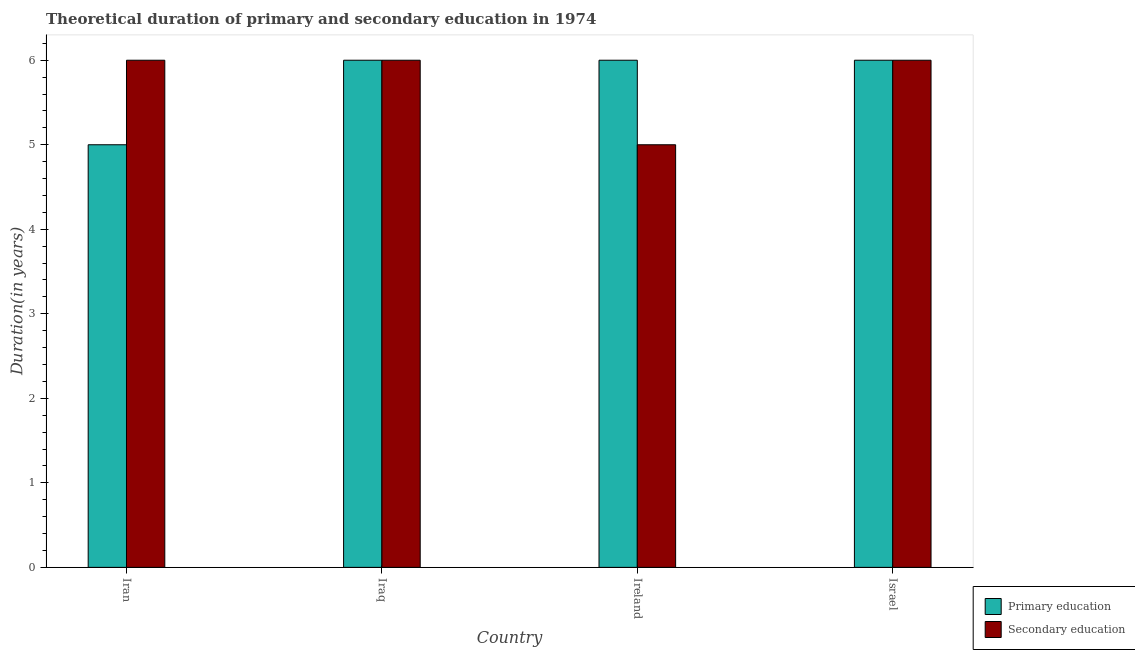How many bars are there on the 4th tick from the left?
Your answer should be compact. 2. What is the label of the 2nd group of bars from the left?
Keep it short and to the point. Iraq. In how many cases, is the number of bars for a given country not equal to the number of legend labels?
Your response must be concise. 0. Across all countries, what is the maximum duration of primary education?
Your answer should be very brief. 6. Across all countries, what is the minimum duration of secondary education?
Provide a succinct answer. 5. In which country was the duration of secondary education maximum?
Your answer should be compact. Iran. In which country was the duration of primary education minimum?
Offer a terse response. Iran. What is the total duration of secondary education in the graph?
Offer a terse response. 23. What is the difference between the duration of primary education in Israel and the duration of secondary education in Ireland?
Give a very brief answer. 1. What is the average duration of secondary education per country?
Ensure brevity in your answer.  5.75. What is the difference between the duration of secondary education and duration of primary education in Iran?
Your answer should be compact. 1. In how many countries, is the duration of secondary education greater than 1.8 years?
Keep it short and to the point. 4. Is the duration of primary education in Iran less than that in Israel?
Your answer should be compact. Yes. What is the difference between the highest and the lowest duration of secondary education?
Offer a very short reply. 1. In how many countries, is the duration of secondary education greater than the average duration of secondary education taken over all countries?
Give a very brief answer. 3. What does the 2nd bar from the left in Iran represents?
Give a very brief answer. Secondary education. What does the 2nd bar from the right in Ireland represents?
Offer a terse response. Primary education. Are all the bars in the graph horizontal?
Give a very brief answer. No. How many countries are there in the graph?
Your answer should be very brief. 4. What is the difference between two consecutive major ticks on the Y-axis?
Your response must be concise. 1. Does the graph contain any zero values?
Your answer should be very brief. No. Does the graph contain grids?
Provide a succinct answer. No. Where does the legend appear in the graph?
Provide a short and direct response. Bottom right. How are the legend labels stacked?
Provide a succinct answer. Vertical. What is the title of the graph?
Provide a succinct answer. Theoretical duration of primary and secondary education in 1974. What is the label or title of the X-axis?
Offer a terse response. Country. What is the label or title of the Y-axis?
Ensure brevity in your answer.  Duration(in years). What is the Duration(in years) in Primary education in Ireland?
Your response must be concise. 6. What is the Duration(in years) of Primary education in Israel?
Your answer should be very brief. 6. What is the Duration(in years) of Secondary education in Israel?
Keep it short and to the point. 6. Across all countries, what is the maximum Duration(in years) of Primary education?
Your response must be concise. 6. Across all countries, what is the maximum Duration(in years) of Secondary education?
Offer a terse response. 6. What is the total Duration(in years) in Primary education in the graph?
Provide a succinct answer. 23. What is the total Duration(in years) of Secondary education in the graph?
Make the answer very short. 23. What is the difference between the Duration(in years) of Primary education in Iran and that in Iraq?
Provide a succinct answer. -1. What is the difference between the Duration(in years) in Secondary education in Iran and that in Iraq?
Your response must be concise. 0. What is the difference between the Duration(in years) in Primary education in Iran and that in Ireland?
Ensure brevity in your answer.  -1. What is the difference between the Duration(in years) of Secondary education in Iran and that in Ireland?
Keep it short and to the point. 1. What is the difference between the Duration(in years) in Primary education in Iran and that in Israel?
Provide a short and direct response. -1. What is the difference between the Duration(in years) of Secondary education in Iraq and that in Ireland?
Your answer should be very brief. 1. What is the difference between the Duration(in years) in Primary education in Ireland and that in Israel?
Your response must be concise. 0. What is the difference between the Duration(in years) in Secondary education in Ireland and that in Israel?
Your response must be concise. -1. What is the difference between the Duration(in years) in Primary education in Iran and the Duration(in years) in Secondary education in Iraq?
Keep it short and to the point. -1. What is the difference between the Duration(in years) in Primary education in Ireland and the Duration(in years) in Secondary education in Israel?
Offer a terse response. 0. What is the average Duration(in years) in Primary education per country?
Offer a very short reply. 5.75. What is the average Duration(in years) of Secondary education per country?
Your answer should be compact. 5.75. What is the difference between the Duration(in years) in Primary education and Duration(in years) in Secondary education in Iraq?
Offer a terse response. 0. What is the ratio of the Duration(in years) of Primary education in Iran to that in Iraq?
Your answer should be compact. 0.83. What is the ratio of the Duration(in years) in Primary education in Iran to that in Ireland?
Offer a very short reply. 0.83. What is the ratio of the Duration(in years) in Secondary education in Iran to that in Israel?
Make the answer very short. 1. What is the ratio of the Duration(in years) of Primary education in Iraq to that in Ireland?
Offer a very short reply. 1. What is the ratio of the Duration(in years) in Secondary education in Iraq to that in Israel?
Provide a succinct answer. 1. What is the ratio of the Duration(in years) of Secondary education in Ireland to that in Israel?
Ensure brevity in your answer.  0.83. What is the difference between the highest and the second highest Duration(in years) of Secondary education?
Provide a succinct answer. 0. What is the difference between the highest and the lowest Duration(in years) in Secondary education?
Your response must be concise. 1. 